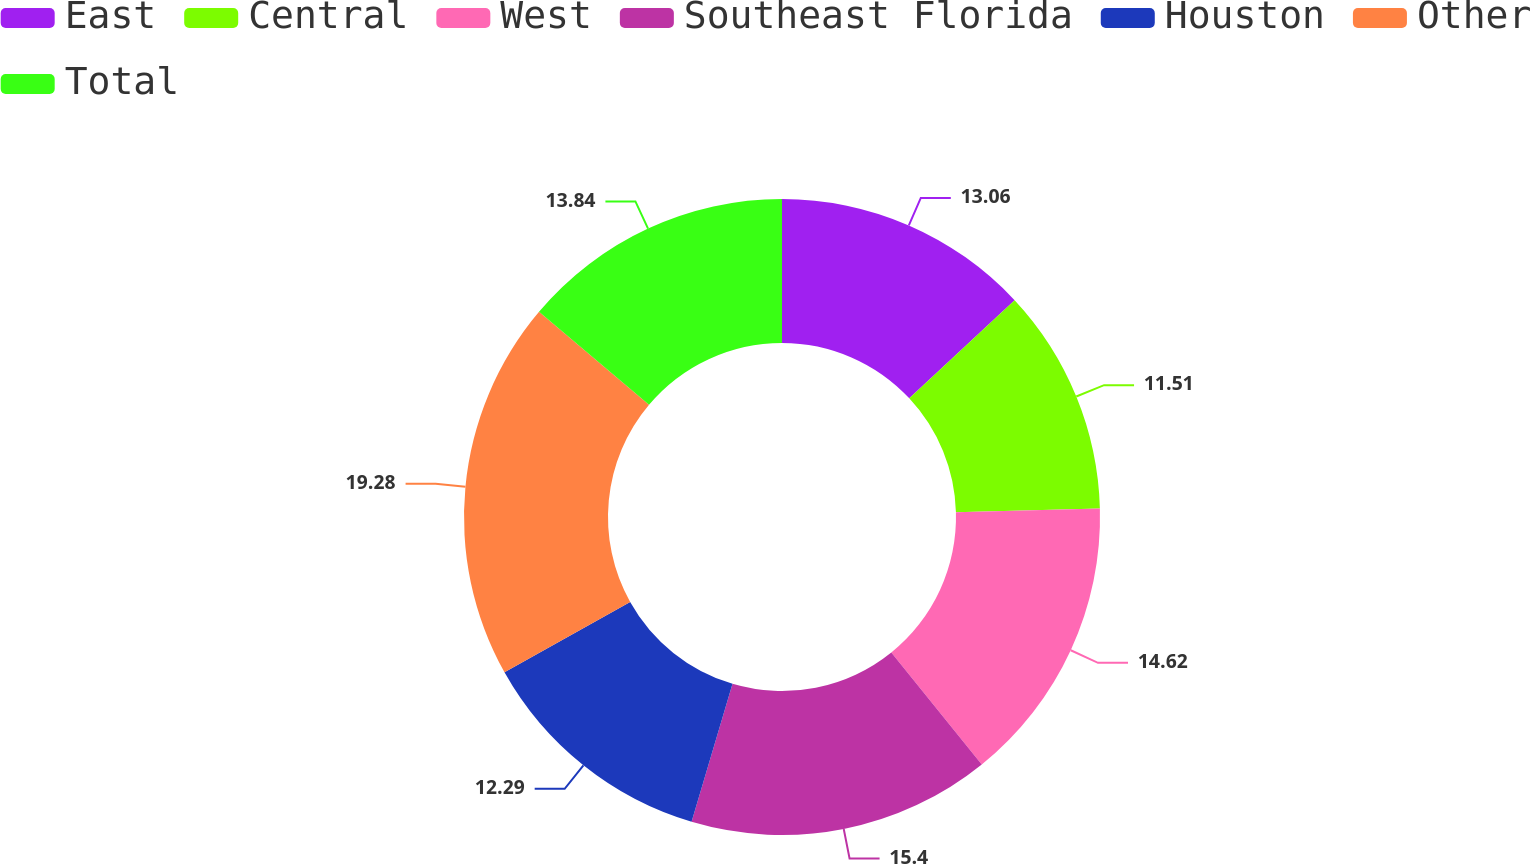Convert chart. <chart><loc_0><loc_0><loc_500><loc_500><pie_chart><fcel>East<fcel>Central<fcel>West<fcel>Southeast Florida<fcel>Houston<fcel>Other<fcel>Total<nl><fcel>13.06%<fcel>11.51%<fcel>14.62%<fcel>15.4%<fcel>12.29%<fcel>19.28%<fcel>13.84%<nl></chart> 